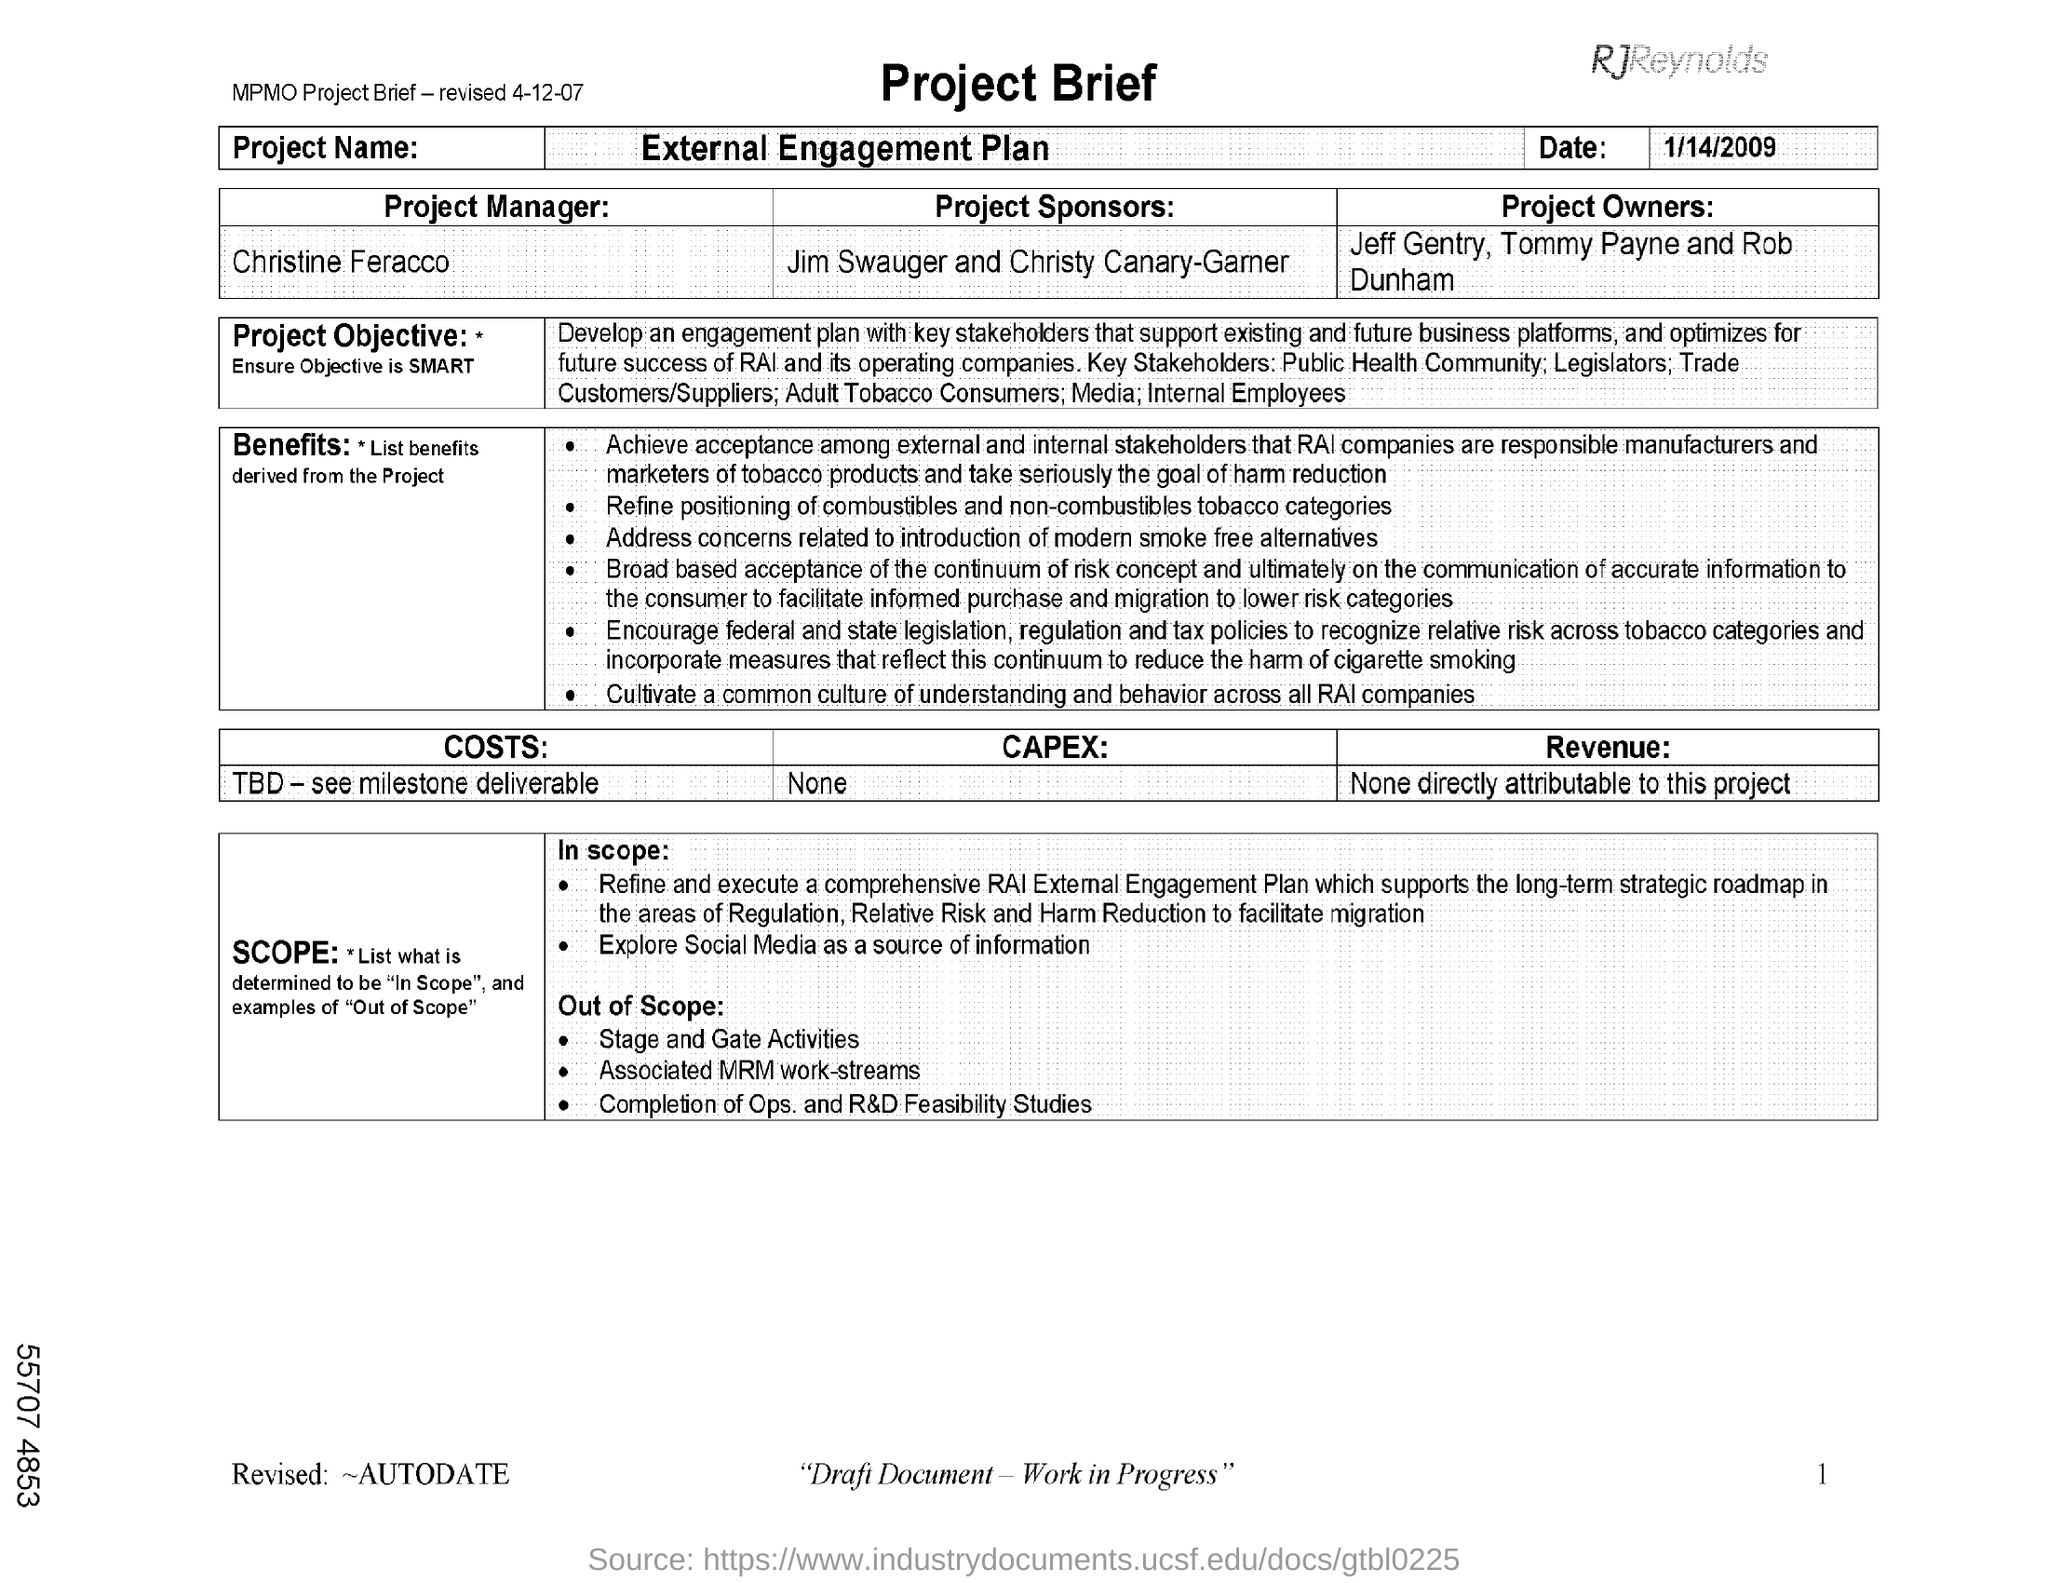Who is the Project Manager?
Keep it short and to the point. Christine Feracco. What is the Project Name?
Make the answer very short. External Engagement Plan. What is the date mentioned in the document?
Provide a short and direct response. 1/14/2009. 